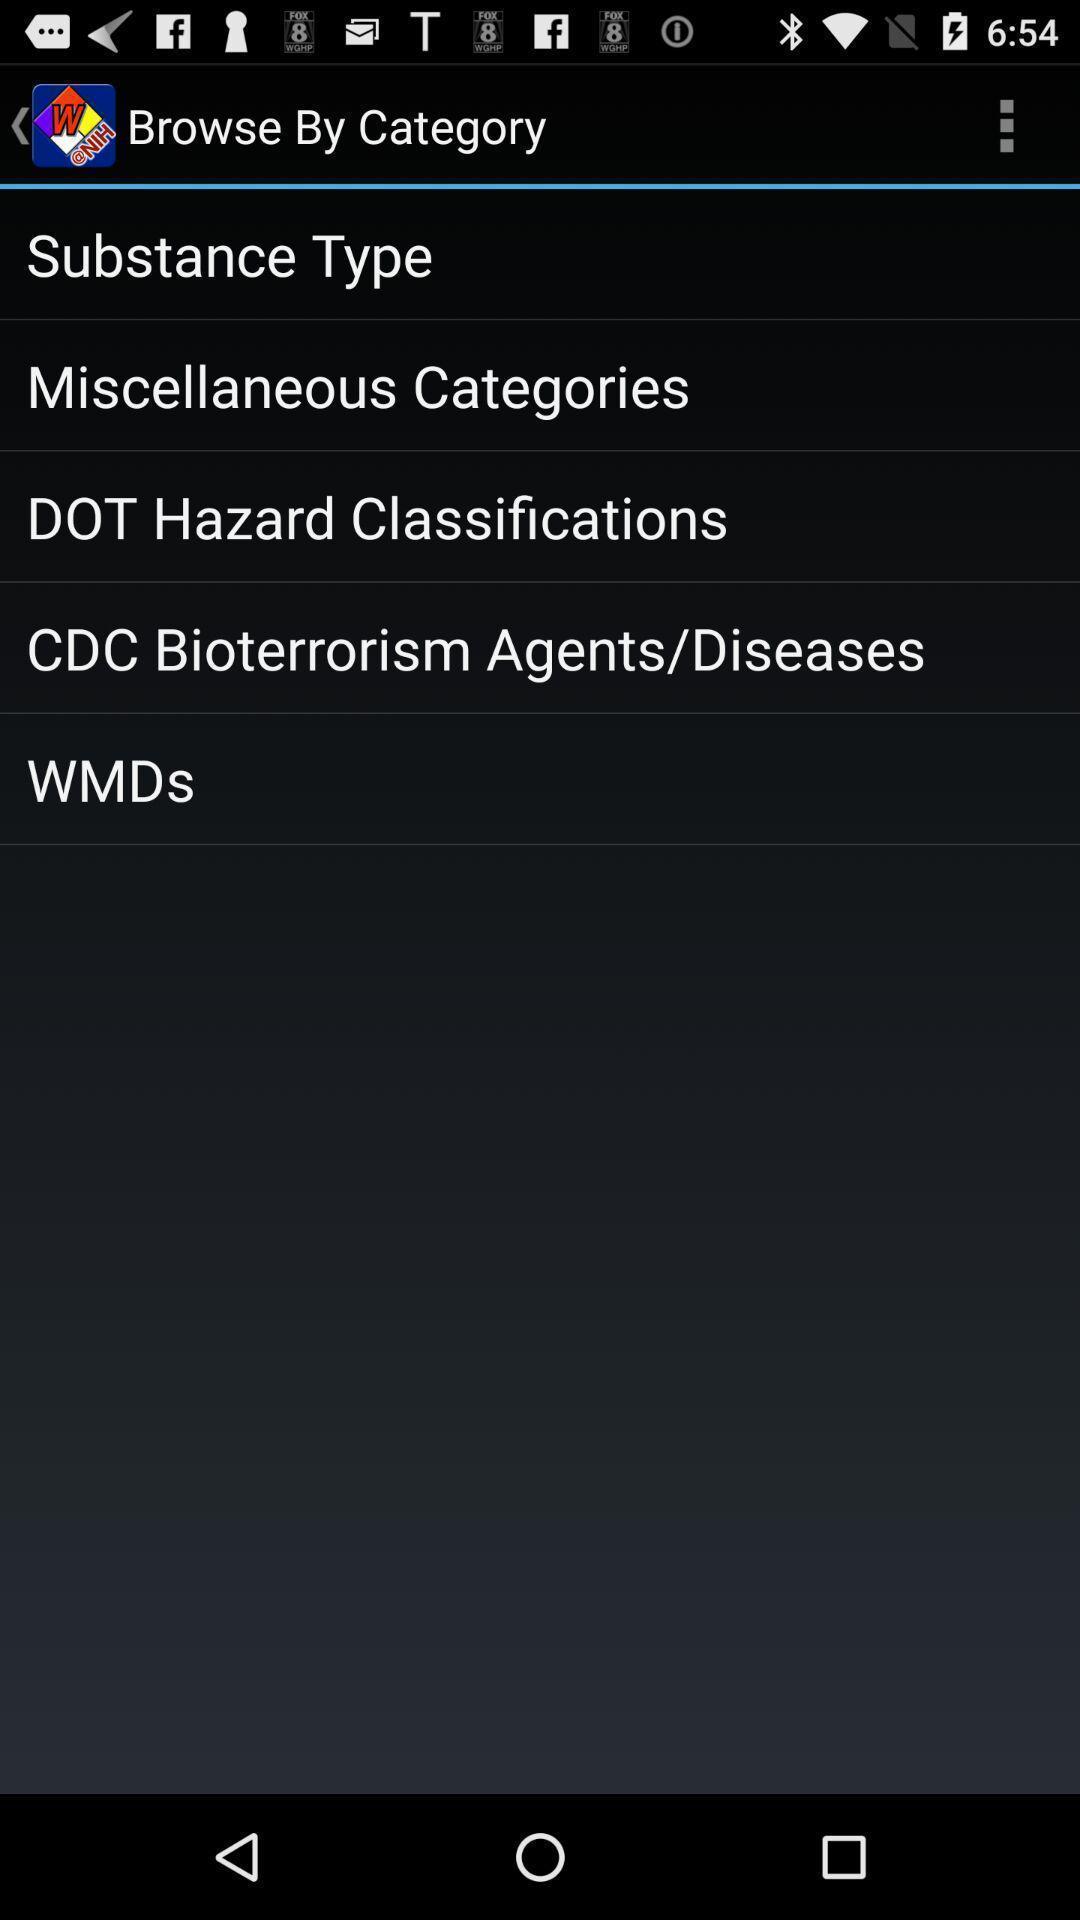Give me a summary of this screen capture. Screen showing different categories to browse. 